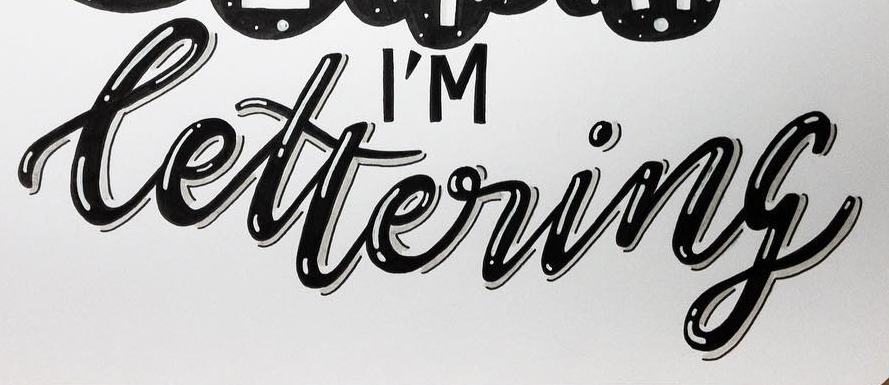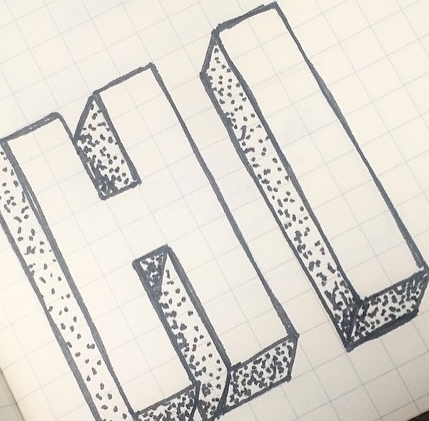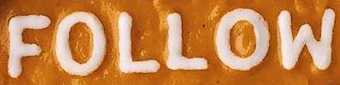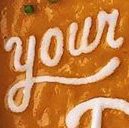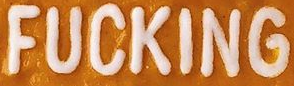What words can you see in these images in sequence, separated by a semicolon? lettering; HI; FOLLOW; Your; FUCKING 